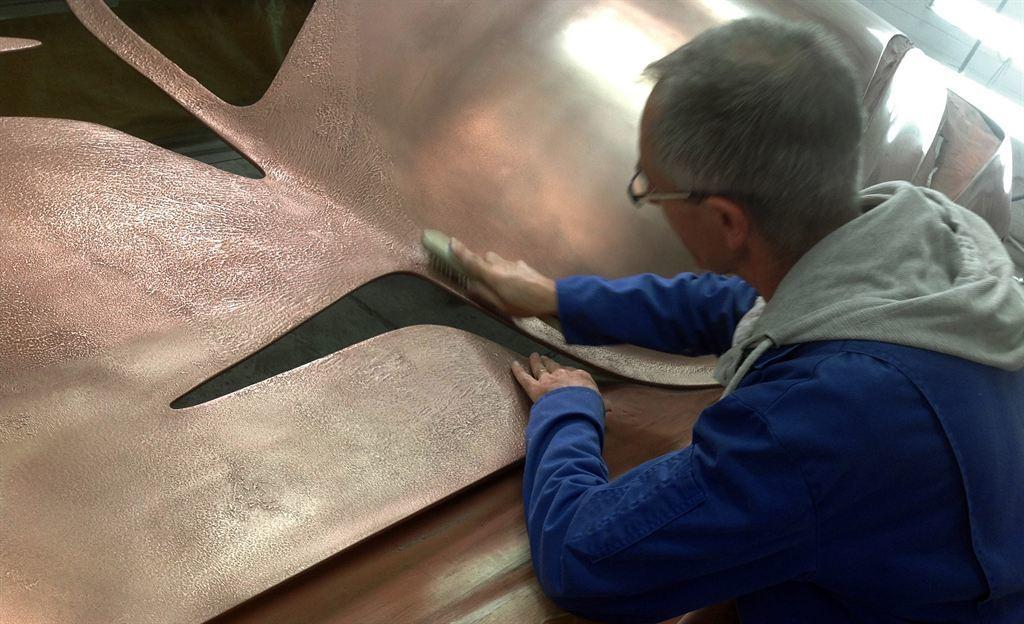What is the person doing on the right side of the image? The person is brushing an object on the right side of the image. What can be seen beneath the person and the object they are brushing? There is a surface visible in the image. Where is the light source coming from in the image? There is light in the top right corner of the image. What type of stocking is the person wearing on their left foot in the image? There is no information about the person's clothing or footwear in the image, so it cannot be determined if they are wearing a stocking or not. 